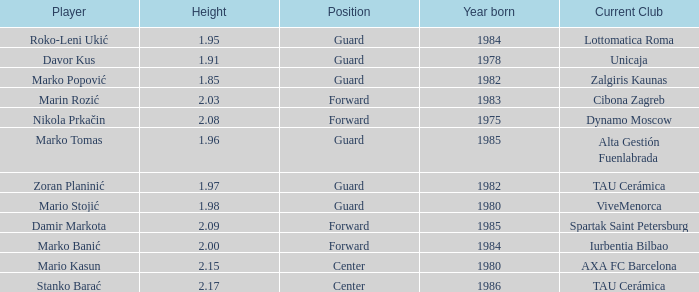What is the height of the player who currently plays for Alta Gestión Fuenlabrada? 1.96. 